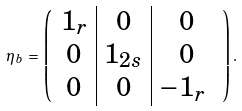<formula> <loc_0><loc_0><loc_500><loc_500>\eta _ { b } \, = \, \left ( \begin{array} { c | c | c } 1 _ { r } & 0 & 0 \\ 0 & 1 _ { 2 s } & 0 \\ 0 & 0 & - 1 _ { r } \ \end{array} \right ) .</formula> 